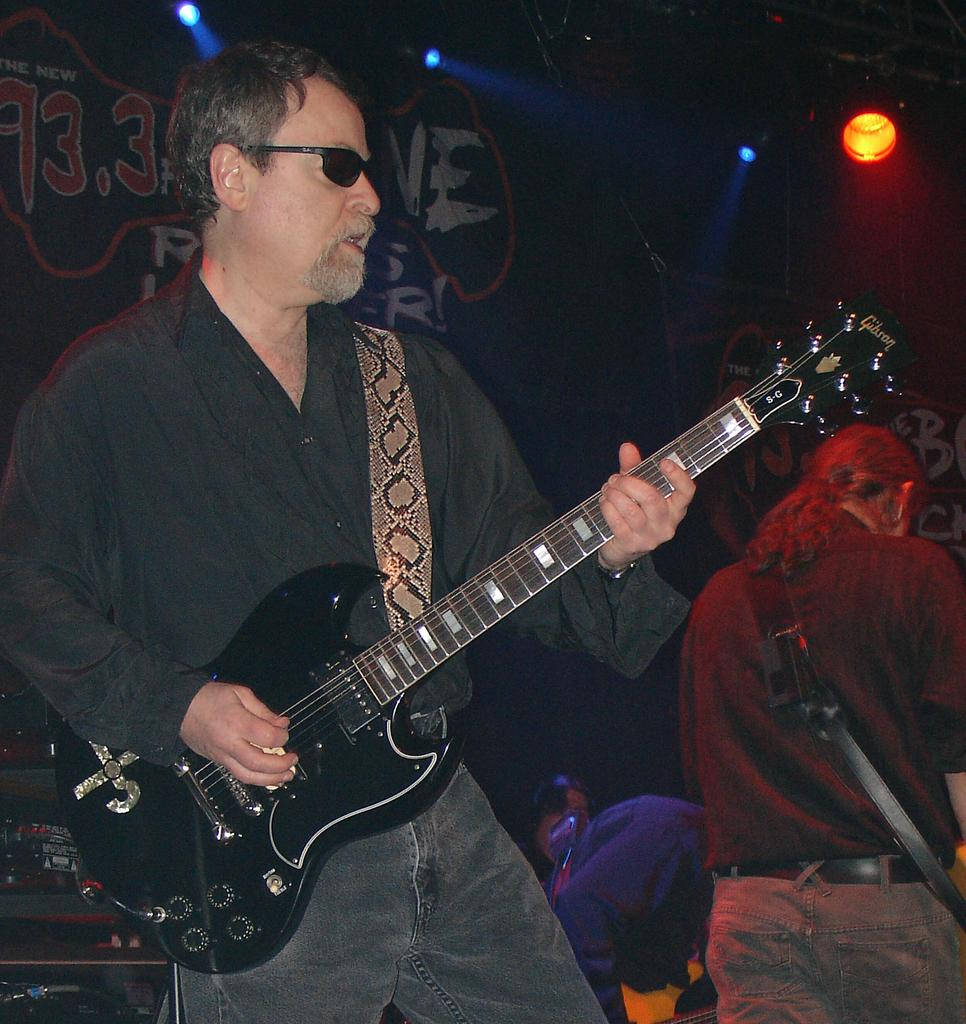What is the man in the image doing? The man in the image is standing and playing a guitar. Can you describe the other person in the image? There is another person standing in the background of the image. What can be seen in the image that is used for lighting? There is a focus light in the image. What is hanging in the image? There is a banner in the image. What type of club does the boy use to play the guitar in the image? There is no boy present in the image, and the man playing the guitar is not using a club. 